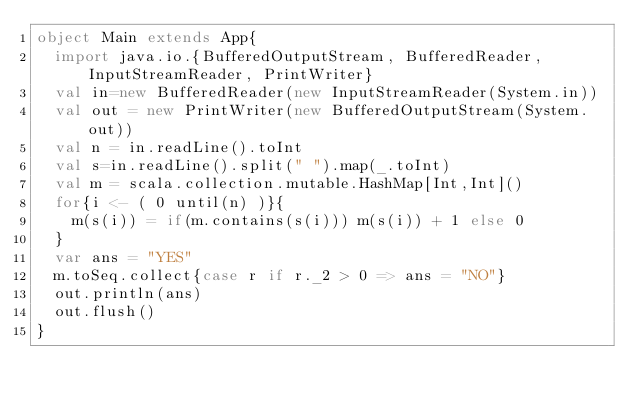<code> <loc_0><loc_0><loc_500><loc_500><_Scala_>object Main extends App{
  import java.io.{BufferedOutputStream, BufferedReader, InputStreamReader, PrintWriter}
  val in=new BufferedReader(new InputStreamReader(System.in))
  val out = new PrintWriter(new BufferedOutputStream(System.out))
  val n = in.readLine().toInt
  val s=in.readLine().split(" ").map(_.toInt)
  val m = scala.collection.mutable.HashMap[Int,Int]()
  for{i <- ( 0 until(n) )}{
    m(s(i)) = if(m.contains(s(i))) m(s(i)) + 1 else 0
  }
  var ans = "YES"
  m.toSeq.collect{case r if r._2 > 0 => ans = "NO"}
  out.println(ans)
  out.flush()
}</code> 